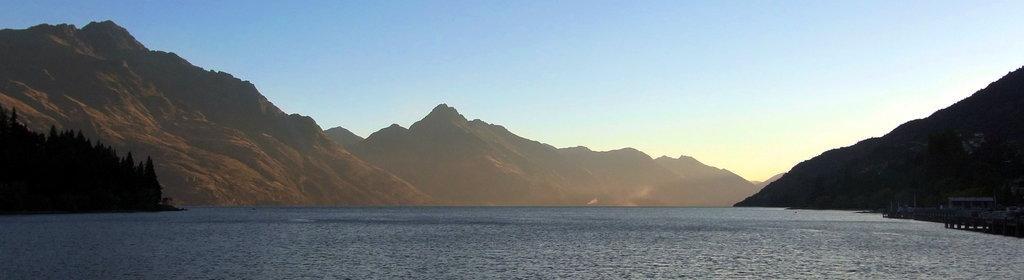Please provide a concise description of this image. It is a beautiful scenery there is a sea and around the sea there are many mountains and in the right side there is a small bridge beside the sea. 